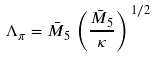Convert formula to latex. <formula><loc_0><loc_0><loc_500><loc_500>\Lambda _ { \pi } = \bar { M } _ { 5 } \, \left ( \frac { \bar { M } _ { 5 } } { \kappa } \right ) ^ { \, 1 / 2 }</formula> 